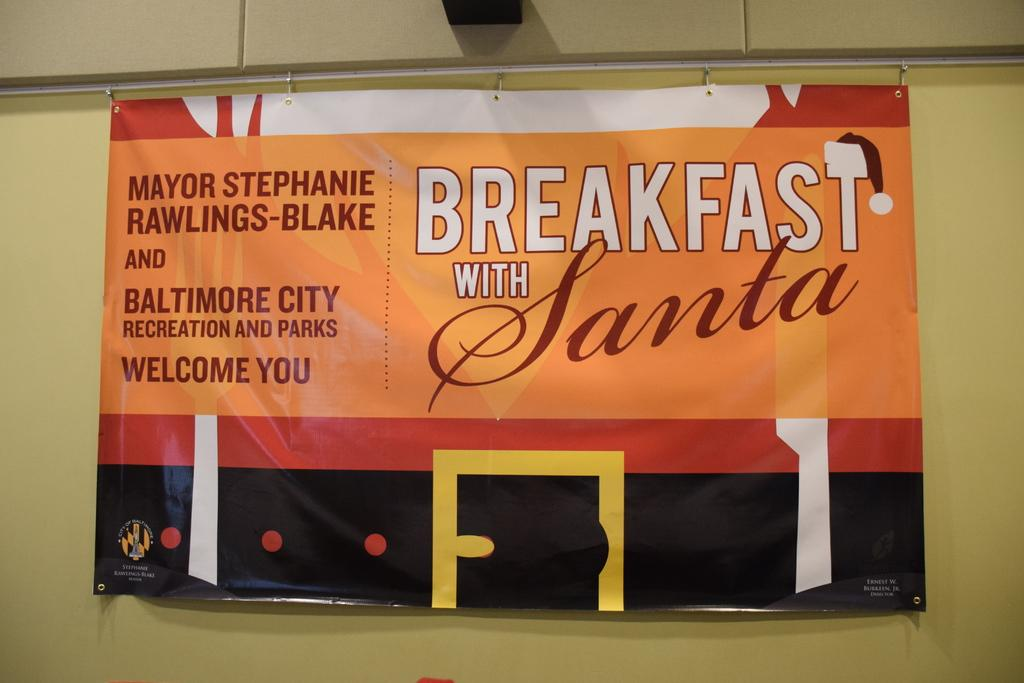<image>
Share a concise interpretation of the image provided. A large sign that reads breakfast with Santa is handing from an iron bar. 